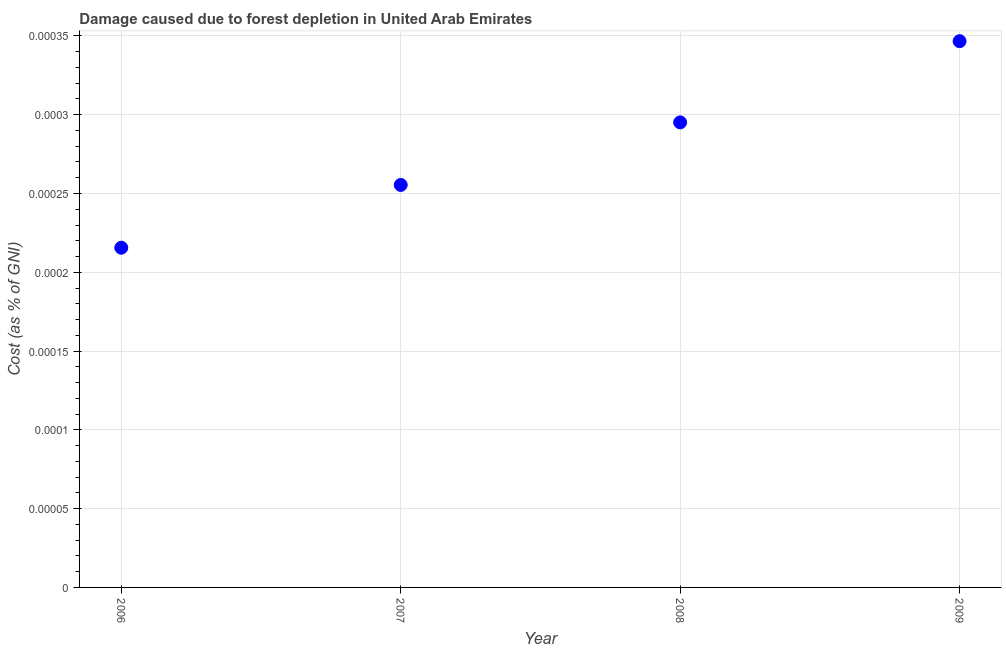What is the damage caused due to forest depletion in 2009?
Your response must be concise. 0. Across all years, what is the maximum damage caused due to forest depletion?
Your answer should be very brief. 0. Across all years, what is the minimum damage caused due to forest depletion?
Provide a short and direct response. 0. In which year was the damage caused due to forest depletion maximum?
Provide a short and direct response. 2009. What is the sum of the damage caused due to forest depletion?
Make the answer very short. 0. What is the difference between the damage caused due to forest depletion in 2007 and 2008?
Provide a succinct answer. -3.969403711912001e-5. What is the average damage caused due to forest depletion per year?
Offer a very short reply. 0. What is the median damage caused due to forest depletion?
Provide a short and direct response. 0. Do a majority of the years between 2006 and 2007 (inclusive) have damage caused due to forest depletion greater than 0.00011 %?
Make the answer very short. Yes. What is the ratio of the damage caused due to forest depletion in 2006 to that in 2009?
Keep it short and to the point. 0.62. Is the damage caused due to forest depletion in 2008 less than that in 2009?
Make the answer very short. Yes. Is the difference between the damage caused due to forest depletion in 2006 and 2007 greater than the difference between any two years?
Offer a very short reply. No. What is the difference between the highest and the second highest damage caused due to forest depletion?
Give a very brief answer. 5.155105180345399e-5. What is the difference between the highest and the lowest damage caused due to forest depletion?
Make the answer very short. 0. How many years are there in the graph?
Provide a short and direct response. 4. What is the difference between two consecutive major ticks on the Y-axis?
Offer a very short reply. 5e-5. What is the title of the graph?
Provide a succinct answer. Damage caused due to forest depletion in United Arab Emirates. What is the label or title of the X-axis?
Provide a short and direct response. Year. What is the label or title of the Y-axis?
Your answer should be compact. Cost (as % of GNI). What is the Cost (as % of GNI) in 2006?
Make the answer very short. 0. What is the Cost (as % of GNI) in 2007?
Provide a succinct answer. 0. What is the Cost (as % of GNI) in 2008?
Offer a terse response. 0. What is the Cost (as % of GNI) in 2009?
Offer a very short reply. 0. What is the difference between the Cost (as % of GNI) in 2006 and 2007?
Your answer should be very brief. -4e-5. What is the difference between the Cost (as % of GNI) in 2006 and 2008?
Provide a short and direct response. -8e-5. What is the difference between the Cost (as % of GNI) in 2006 and 2009?
Keep it short and to the point. -0. What is the difference between the Cost (as % of GNI) in 2007 and 2008?
Your answer should be very brief. -4e-5. What is the difference between the Cost (as % of GNI) in 2007 and 2009?
Make the answer very short. -9e-5. What is the difference between the Cost (as % of GNI) in 2008 and 2009?
Provide a succinct answer. -5e-5. What is the ratio of the Cost (as % of GNI) in 2006 to that in 2007?
Your response must be concise. 0.84. What is the ratio of the Cost (as % of GNI) in 2006 to that in 2008?
Offer a very short reply. 0.73. What is the ratio of the Cost (as % of GNI) in 2006 to that in 2009?
Provide a short and direct response. 0.62. What is the ratio of the Cost (as % of GNI) in 2007 to that in 2008?
Offer a terse response. 0.87. What is the ratio of the Cost (as % of GNI) in 2007 to that in 2009?
Your response must be concise. 0.74. What is the ratio of the Cost (as % of GNI) in 2008 to that in 2009?
Give a very brief answer. 0.85. 